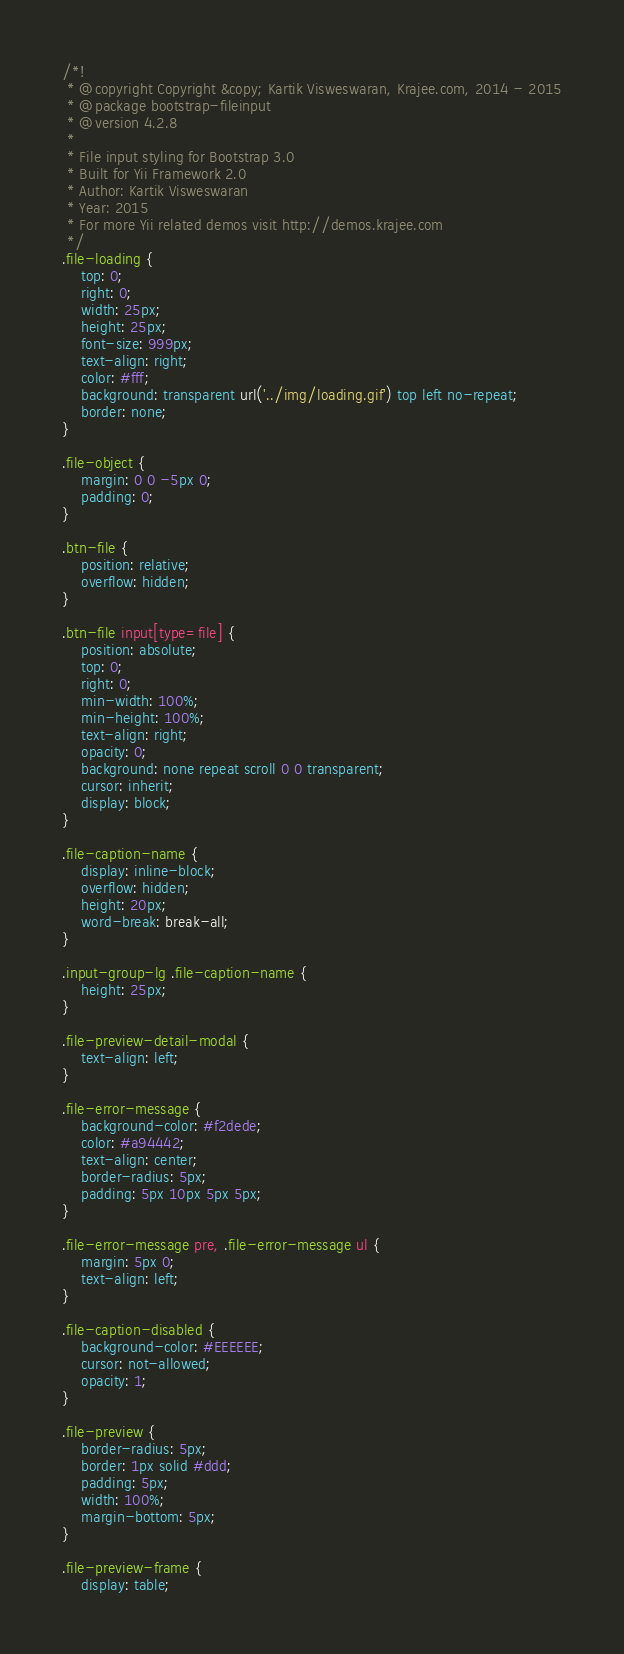<code> <loc_0><loc_0><loc_500><loc_500><_CSS_>/*!
 * @copyright Copyright &copy; Kartik Visweswaran, Krajee.com, 2014 - 2015
 * @package bootstrap-fileinput
 * @version 4.2.8
 *
 * File input styling for Bootstrap 3.0
 * Built for Yii Framework 2.0
 * Author: Kartik Visweswaran
 * Year: 2015
 * For more Yii related demos visit http://demos.krajee.com
 */
.file-loading {
    top: 0;
    right: 0;
    width: 25px;
    height: 25px;
    font-size: 999px;
    text-align: right;
    color: #fff;
    background: transparent url('../img/loading.gif') top left no-repeat;
    border: none;
}

.file-object {
    margin: 0 0 -5px 0;
    padding: 0;
}

.btn-file {
    position: relative;
    overflow: hidden;
}

.btn-file input[type=file] {
    position: absolute;
    top: 0;
    right: 0;
    min-width: 100%;
    min-height: 100%;
    text-align: right;
    opacity: 0;
    background: none repeat scroll 0 0 transparent;
    cursor: inherit;
    display: block;
}

.file-caption-name {
    display: inline-block;
    overflow: hidden;
    height: 20px;
    word-break: break-all;
}

.input-group-lg .file-caption-name {
    height: 25px;
}

.file-preview-detail-modal {
    text-align: left;
}

.file-error-message {
    background-color: #f2dede;
    color: #a94442;
    text-align: center;
    border-radius: 5px;
    padding: 5px 10px 5px 5px;
}

.file-error-message pre, .file-error-message ul {
    margin: 5px 0;
    text-align: left;
}

.file-caption-disabled {
    background-color: #EEEEEE;
    cursor: not-allowed;
    opacity: 1;
}

.file-preview {
    border-radius: 5px;
    border: 1px solid #ddd;
    padding: 5px;
    width: 100%;
    margin-bottom: 5px;
}

.file-preview-frame {
    display: table;</code> 